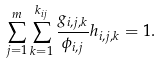<formula> <loc_0><loc_0><loc_500><loc_500>\sum _ { j = 1 } ^ { m } \sum _ { k = 1 } ^ { k _ { i j } } \frac { g _ { i , j , k } } { \phi _ { i , j } } h _ { i , j , k } = 1 .</formula> 